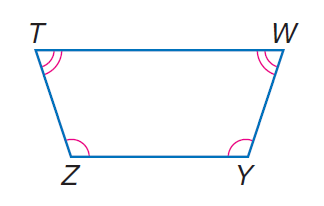Answer the mathemtical geometry problem and directly provide the correct option letter.
Question: isosceles trapezoid T W Y Z with \angle Z \cong \angle Y, m \angle Z = 30 x, \angle T \cong \angle W, and m \angle T = 20 x, find Z.
Choices: A: 62 B: 72 C: 108 D: 118 C 